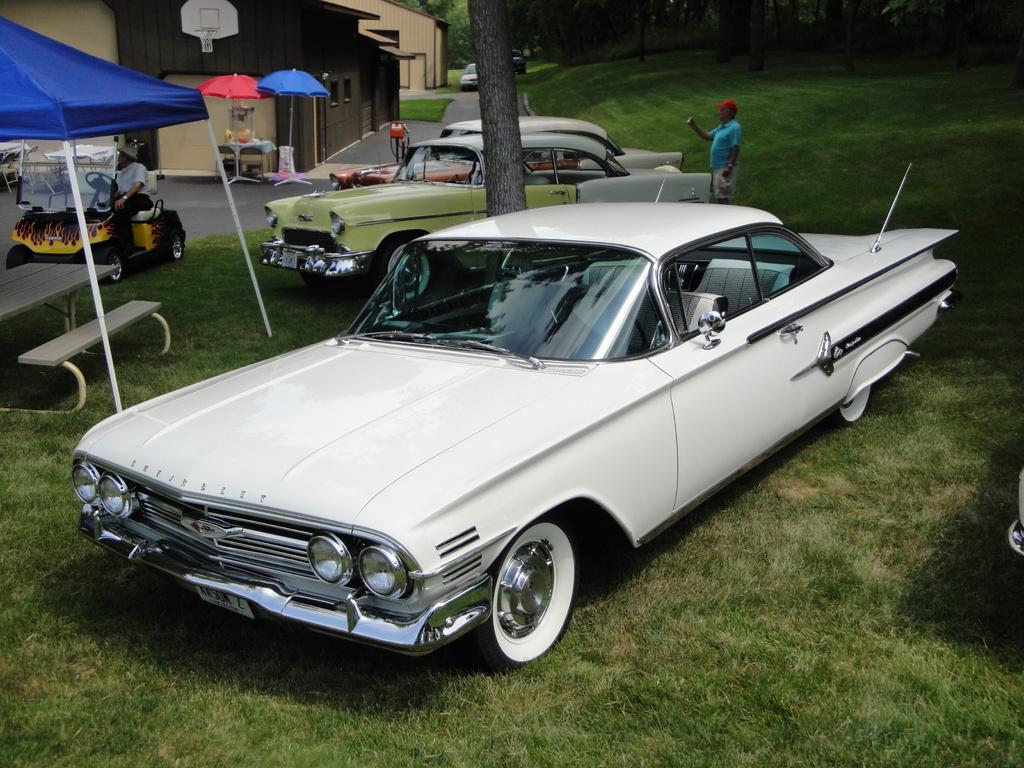Describe this image in one or two sentences. In this picture we can see the grass, cars, tent, bench, vehicle with a person sitting on it and a man standing. In the background we can see buildings, basketball hoop, umbrellas, trees and some objects. 